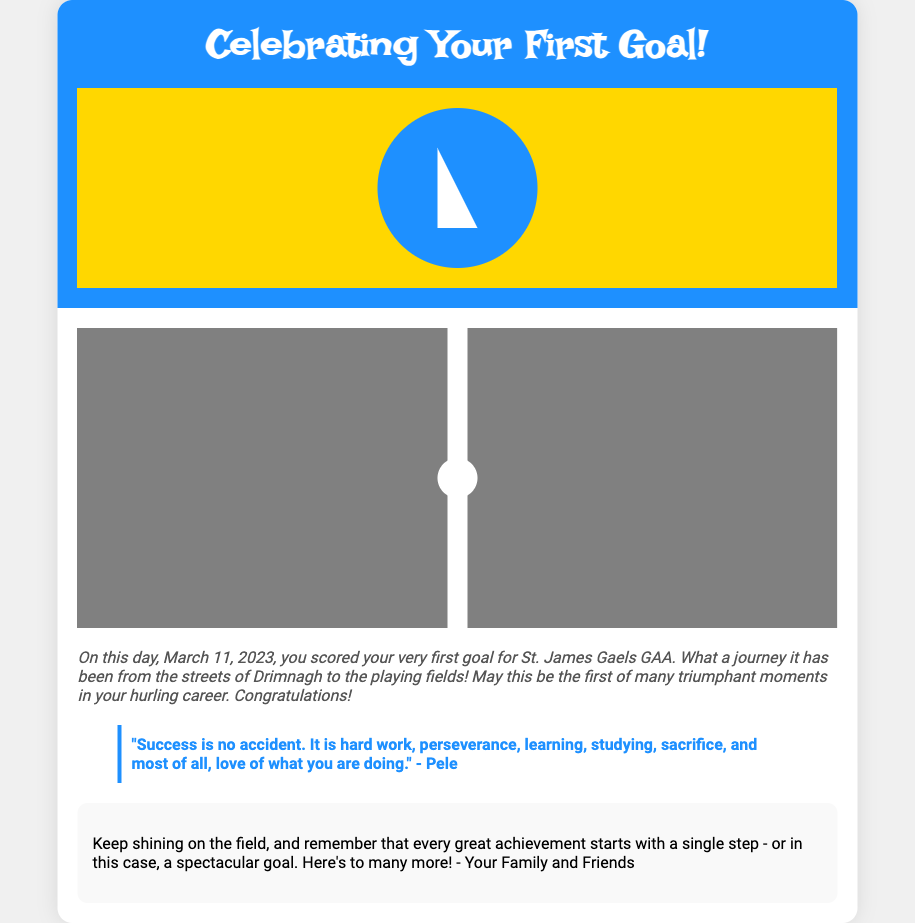What is the title of the card? The title of the card is prominently displayed at the top of the cover section, which is "Celebrating Your First Goal!".
Answer: Celebrating Your First Goal! What date did you score your first goal? The date is mentioned in the caption, specifically stating it is March 11, 2023.
Answer: March 11, 2023 What is the name of your GAA club? The name of the club is mentioned in the caption where it states "for St. James Gaels GAA."
Answer: St. James Gaels GAA What sport is being celebrated in the card? The sport is indicated through the entire theme of the card and captions focused on the achievement, which is hurling.
Answer: Hurling Who is quoted in the blockquote? The blockquote includes a quote attributed to Pele, a well-known figure in sports, implying they are the source of the motivational words.
Answer: Pele What is the main color of the card's cover? The primary color of the card's cover background is blue, as indicated by the code for background color.
Answer: Blue What message is conveyed in the personal message section? The personal message section provides encouragement and emphasizes that every great achievement starts with a single step or goal.
Answer: Keep shining on the field What aspect of your journey is highlighted in the caption? The caption highlights the transition from "the streets of Drimnagh to the playing fields," reflecting on the journey taken.
Answer: Journey from the streets of Drimnagh to the playing fields What does the illustration on the cover represent? The illustration's design is symbolic of a hurling player and celebrates the achievement of scoring a goal.
Answer: A hurling player 